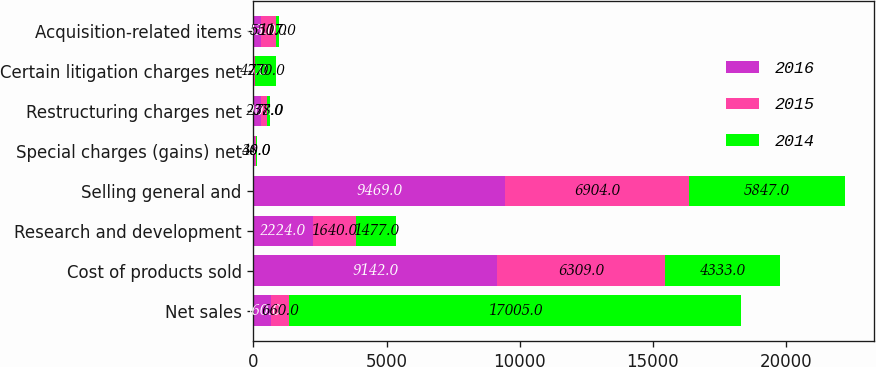Convert chart to OTSL. <chart><loc_0><loc_0><loc_500><loc_500><stacked_bar_chart><ecel><fcel>Net sales<fcel>Cost of products sold<fcel>Research and development<fcel>Selling general and<fcel>Special charges (gains) net<fcel>Restructuring charges net<fcel>Certain litigation charges net<fcel>Acquisition-related items<nl><fcel>2016<fcel>660<fcel>9142<fcel>2224<fcel>9469<fcel>70<fcel>290<fcel>26<fcel>283<nl><fcel>2015<fcel>660<fcel>6309<fcel>1640<fcel>6904<fcel>38<fcel>237<fcel>42<fcel>550<nl><fcel>2014<fcel>17005<fcel>4333<fcel>1477<fcel>5847<fcel>40<fcel>78<fcel>770<fcel>117<nl></chart> 